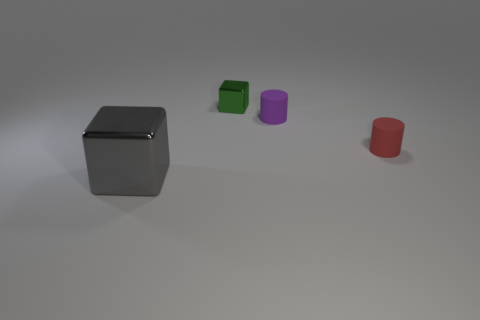How do the objects in the image relate to each other in terms of size? The objects are varying in size, with the large block being the biggest. The green cube is the smallest, while the purple cylinder and red truncated cone are intermediate in size, between the cube and the block. 